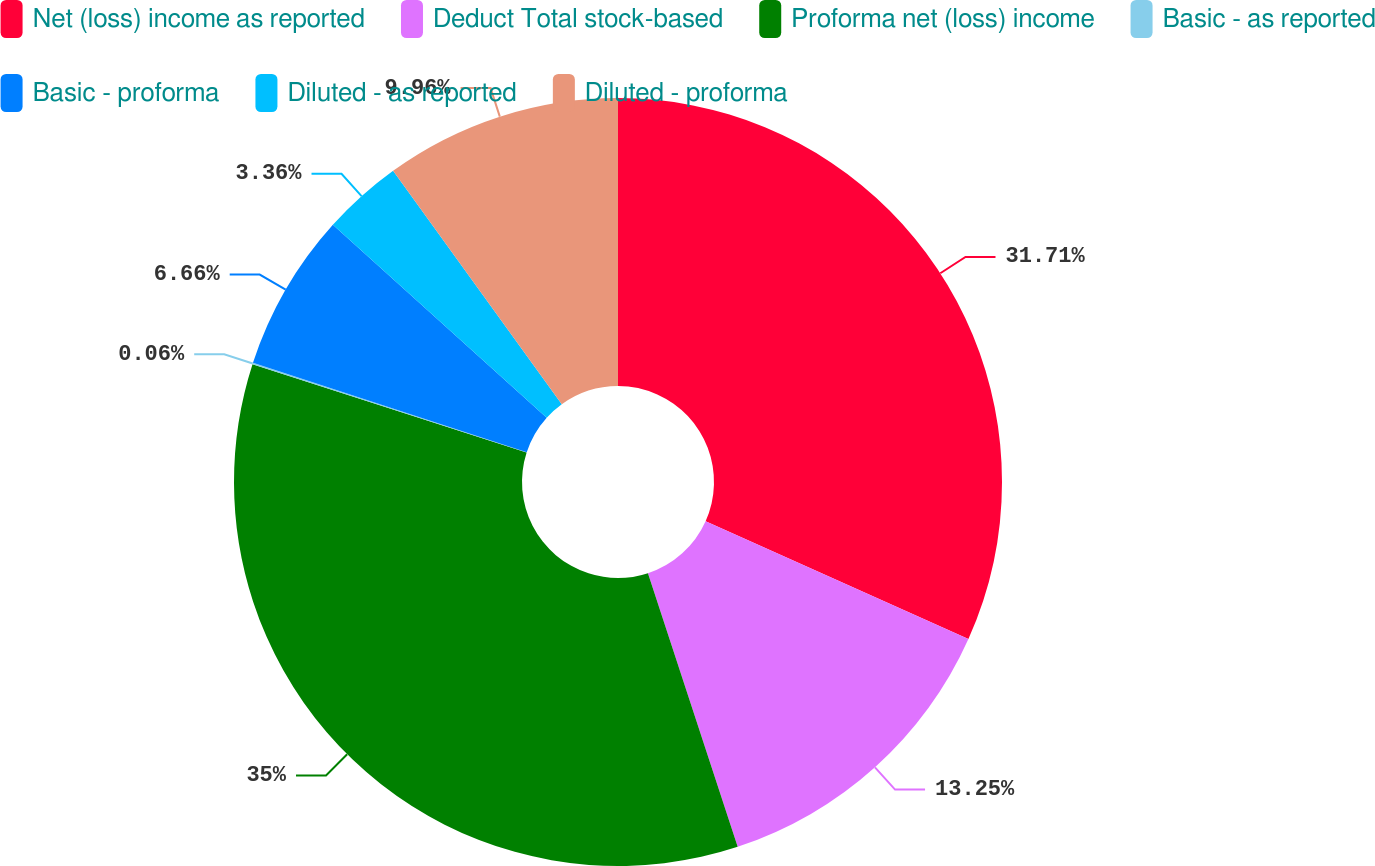Convert chart to OTSL. <chart><loc_0><loc_0><loc_500><loc_500><pie_chart><fcel>Net (loss) income as reported<fcel>Deduct Total stock-based<fcel>Proforma net (loss) income<fcel>Basic - as reported<fcel>Basic - proforma<fcel>Diluted - as reported<fcel>Diluted - proforma<nl><fcel>31.71%<fcel>13.25%<fcel>35.01%<fcel>0.06%<fcel>6.66%<fcel>3.36%<fcel>9.96%<nl></chart> 